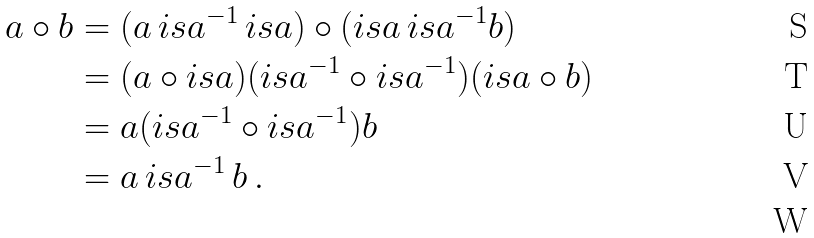<formula> <loc_0><loc_0><loc_500><loc_500>a \circ b & = ( a \, i s a ^ { - 1 } \, i s a ) \circ ( i s a \, i s a ^ { - 1 } b ) \\ & = ( a \circ i s a ) ( i s a ^ { - 1 } \circ i s a ^ { - 1 } ) ( i s a \circ b ) \quad \\ & = a ( i s a ^ { - 1 } \circ i s a ^ { - 1 } ) b \\ & = a \, i s a ^ { - 1 } \, b \, . \\</formula> 